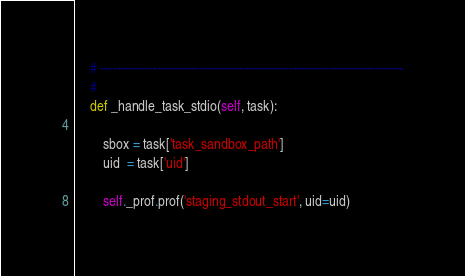<code> <loc_0><loc_0><loc_500><loc_500><_Python_>    # --------------------------------------------------------------------------
    #
    def _handle_task_stdio(self, task):

        sbox = task['task_sandbox_path']
        uid  = task['uid']

        self._prof.prof('staging_stdout_start', uid=uid)</code> 